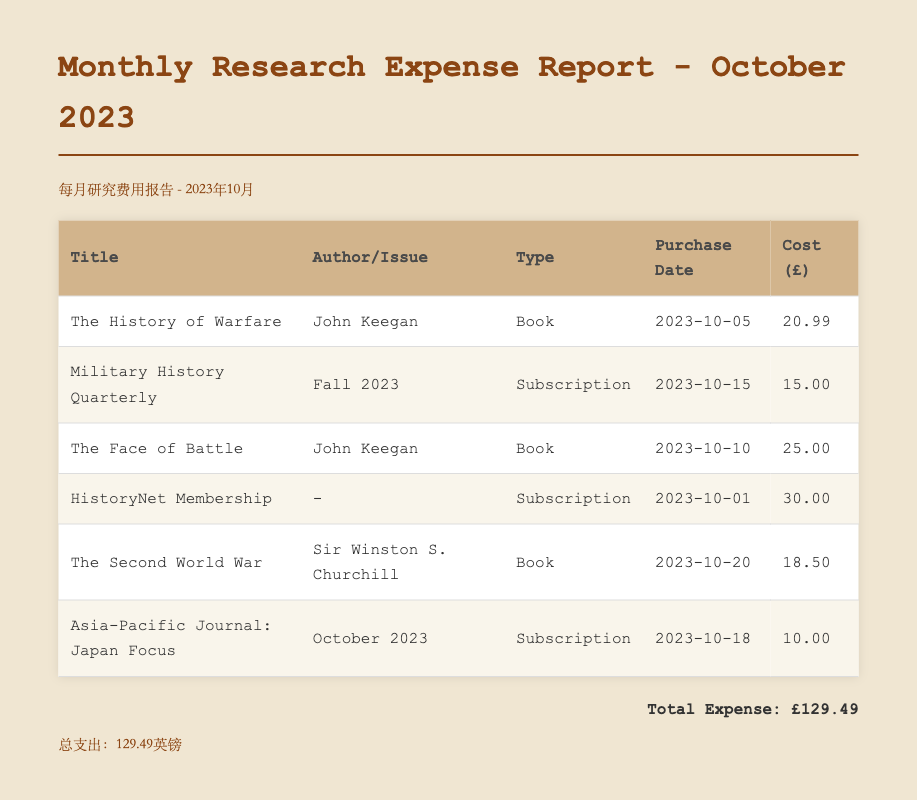What is the total expense? The total expense is calculated by summing all individual costs listed in the document, which totals £129.49.
Answer: £129.49 When was "The History of Warfare" purchased? The purchase date for "The History of Warfare" is detailed in the document as October 5, 2023.
Answer: 2023-10-05 Who is the author of "The Face of Battle"? The author of "The Face of Battle" is specified in the document as John Keegan.
Answer: John Keegan What type of expense is "Military History Quarterly"? The document categorizes "Military History Quarterly" as a subscription expense.
Answer: Subscription How much was spent on book purchases? The total spent on books can be calculated from individual book costs, which totals £64.49 (£20.99 + £25.00 + £18.50).
Answer: £64.49 What is the cost of the "HistoryNet Membership"? The cost for the "HistoryNet Membership" is explicitly stated in the document as £30.00.
Answer: £30.00 What is the purchase date for "Asia-Pacific Journal: Japan Focus"? The purchase date for "Asia-Pacific Journal: Japan Focus" is given in the document as October 18, 2023.
Answer: 2023-10-18 How many subscriptions are listed in the report? The report lists a total of 3 subscription expenses, counted from the document.
Answer: 3 What is the title of the last book listed? The title of the last book listed in the document is "The Second World War."
Answer: The Second World War 